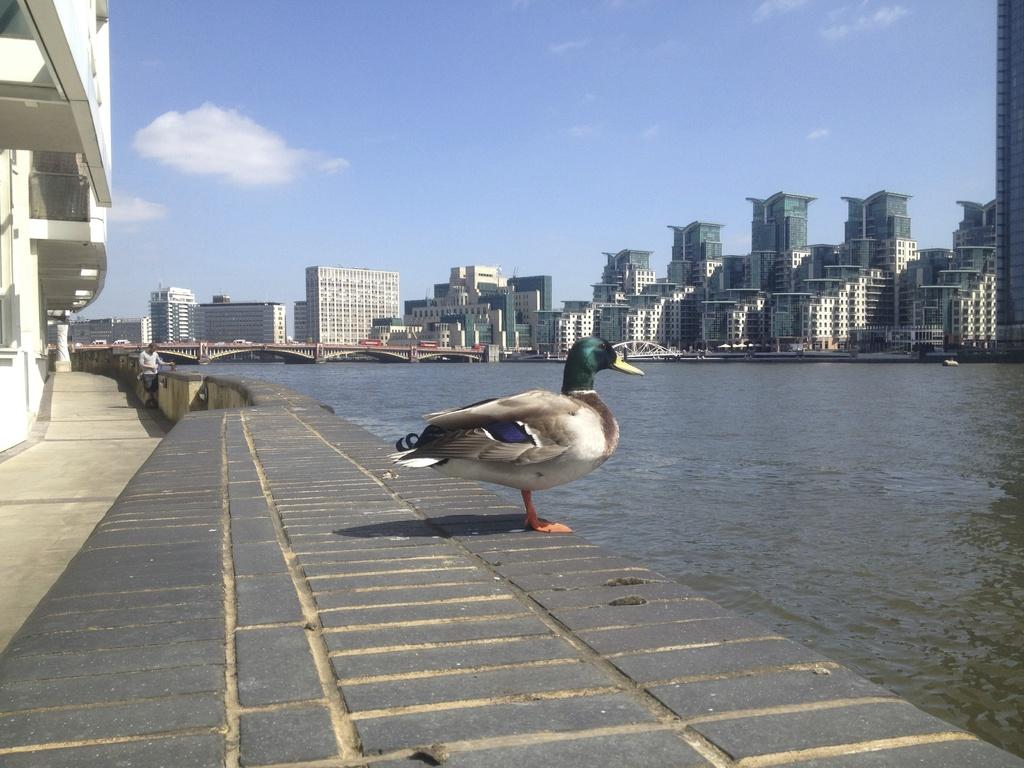What type of structures can be seen in the image? There are buildings in the image. What natural element is visible in the image? There is water visible in the image. What type of animal is present in the image? There is a duck in the image. Can you describe the person in the image? There is a person standing in the image. What can be seen in the background of the image? The sky is visible in the background of the image. What type of coat is the duck wearing in the image? There is no coat present on the duck in the image, as ducks do not wear clothing. Where did the person go on vacation in the image? There is no information about a vacation in the image; it only shows a person standing near a duck and water. 